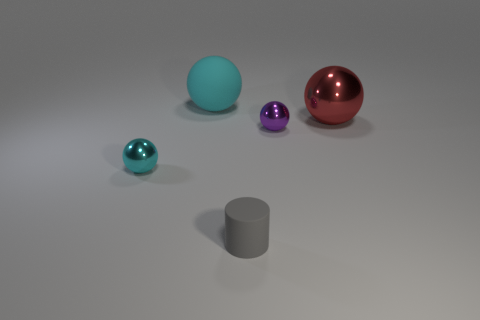Add 3 tiny purple shiny things. How many objects exist? 8 Subtract all small cyan balls. How many balls are left? 3 Subtract all balls. How many objects are left? 1 Subtract 0 gray blocks. How many objects are left? 5 Subtract 2 balls. How many balls are left? 2 Subtract all blue cylinders. Subtract all red blocks. How many cylinders are left? 1 Subtract all gray cubes. How many cyan spheres are left? 2 Subtract all tiny gray cylinders. Subtract all large shiny spheres. How many objects are left? 3 Add 1 red things. How many red things are left? 2 Add 2 tiny gray cylinders. How many tiny gray cylinders exist? 3 